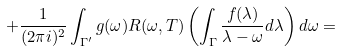<formula> <loc_0><loc_0><loc_500><loc_500>+ \frac { 1 } { ( 2 \pi i ) ^ { 2 } } \int _ { \Gamma ^ { \prime } } g ( \omega ) R ( \omega , T ) \left ( \int _ { \Gamma } \frac { f ( \lambda ) } { \lambda - \omega } d \lambda \right ) d \omega =</formula> 